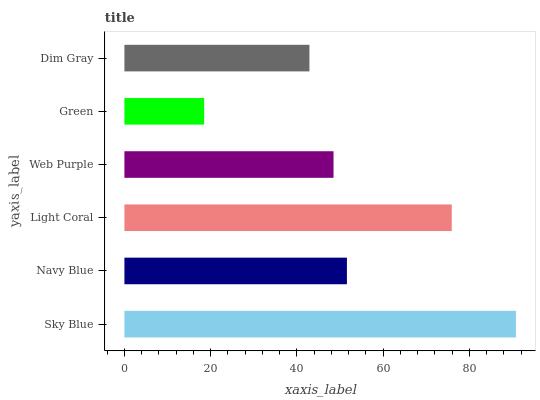Is Green the minimum?
Answer yes or no. Yes. Is Sky Blue the maximum?
Answer yes or no. Yes. Is Navy Blue the minimum?
Answer yes or no. No. Is Navy Blue the maximum?
Answer yes or no. No. Is Sky Blue greater than Navy Blue?
Answer yes or no. Yes. Is Navy Blue less than Sky Blue?
Answer yes or no. Yes. Is Navy Blue greater than Sky Blue?
Answer yes or no. No. Is Sky Blue less than Navy Blue?
Answer yes or no. No. Is Navy Blue the high median?
Answer yes or no. Yes. Is Web Purple the low median?
Answer yes or no. Yes. Is Light Coral the high median?
Answer yes or no. No. Is Dim Gray the low median?
Answer yes or no. No. 